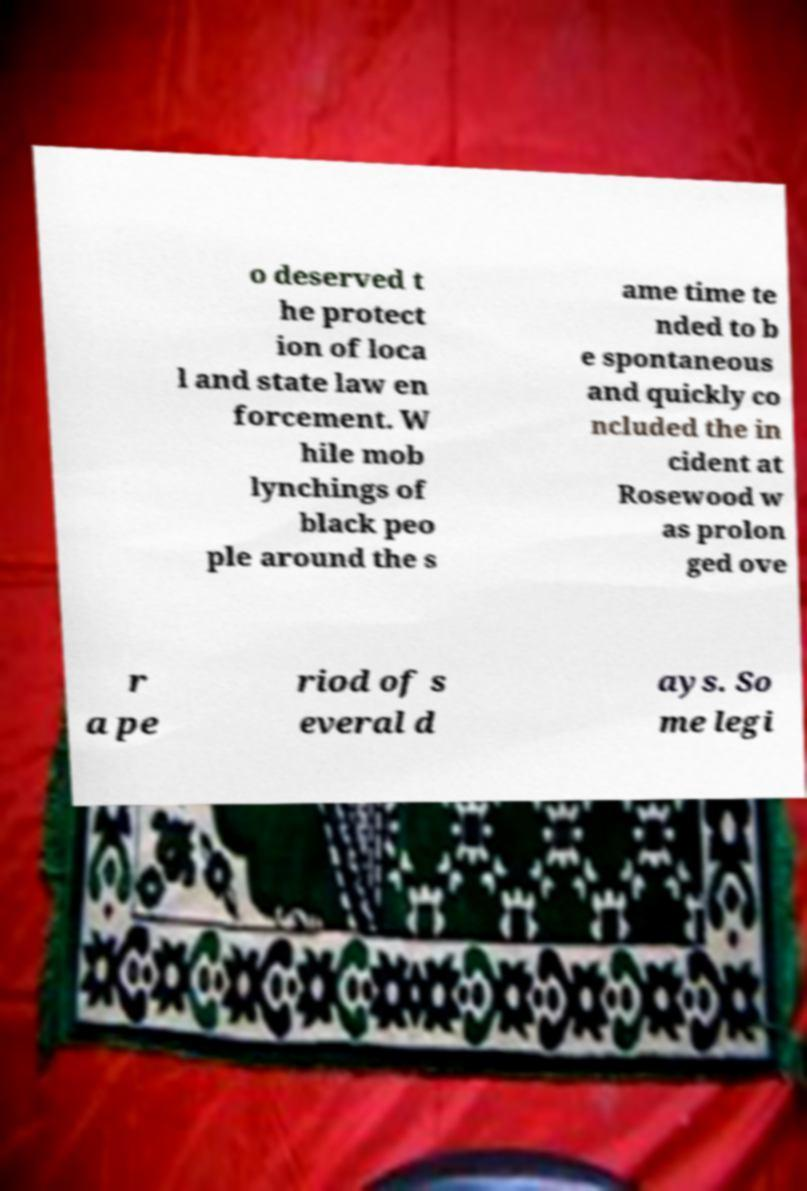For documentation purposes, I need the text within this image transcribed. Could you provide that? o deserved t he protect ion of loca l and state law en forcement. W hile mob lynchings of black peo ple around the s ame time te nded to b e spontaneous and quickly co ncluded the in cident at Rosewood w as prolon ged ove r a pe riod of s everal d ays. So me legi 